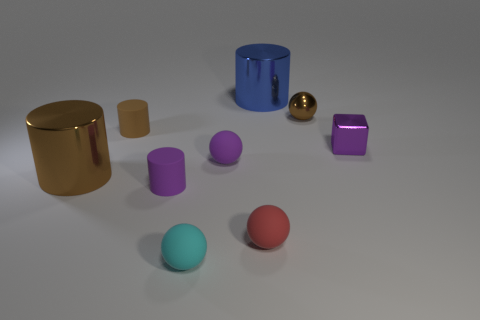What size is the sphere that is both behind the red object and to the left of the small red ball?
Offer a very short reply. Small. How many brown objects are either big metallic objects or metal blocks?
Give a very brief answer. 1. What is the shape of the cyan thing that is the same size as the red rubber object?
Your answer should be very brief. Sphere. How many other things are there of the same color as the metallic cube?
Your answer should be compact. 2. There is a sphere on the right side of the metal cylinder that is behind the purple shiny cube; how big is it?
Keep it short and to the point. Small. Is the large cylinder right of the small cyan rubber thing made of the same material as the tiny purple cylinder?
Your response must be concise. No. There is a small shiny thing that is behind the small brown matte thing; what shape is it?
Your answer should be compact. Sphere. How many red spheres are the same size as the purple shiny cube?
Give a very brief answer. 1. How big is the brown sphere?
Your answer should be very brief. Small. There is a blue metal cylinder; how many brown objects are in front of it?
Your answer should be compact. 3. 